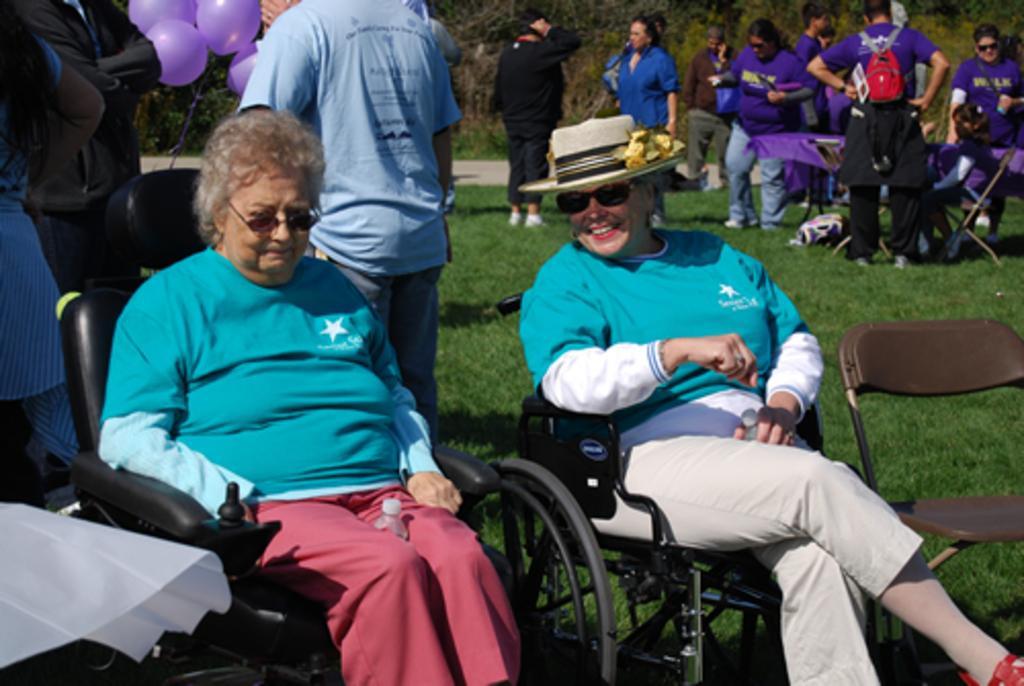In one or two sentences, can you explain what this image depicts? In this image we can see a group of people. And we can see some people sitting in chairs and some are standing. And we can see the grass. And we can see the trees. And we can see the balloons. 